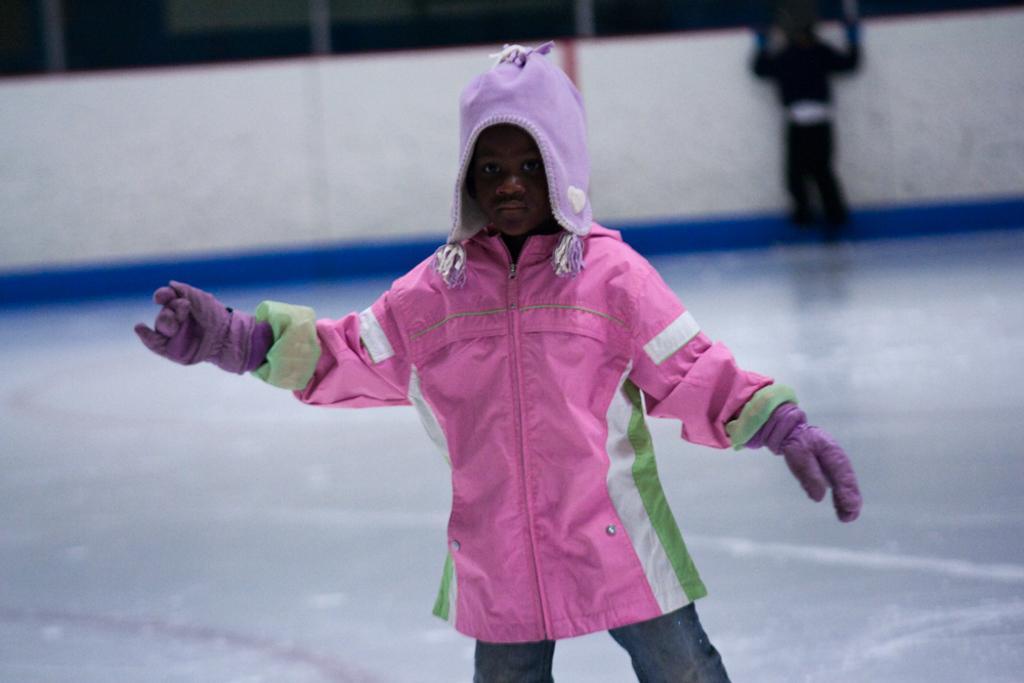In one or two sentences, can you explain what this image depicts? In this picture I can see there is a kid wearing a pink color sweater and purple color head wear. She is standing in the ice and there is another kid standing in the backdrop. 